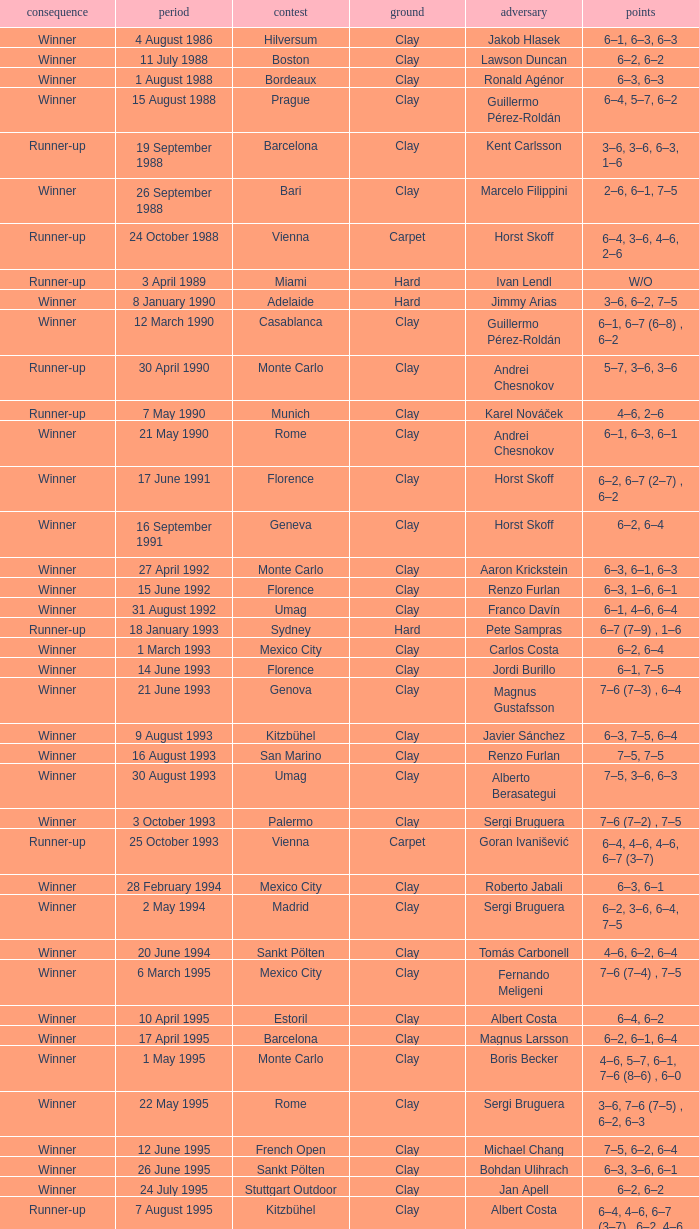Who is the opponent on 18 january 1993? Pete Sampras. 